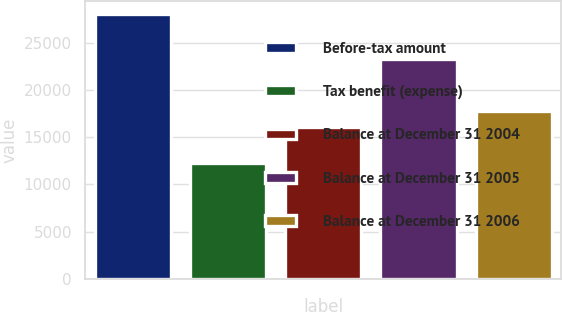Convert chart. <chart><loc_0><loc_0><loc_500><loc_500><bar_chart><fcel>Before-tax amount<fcel>Tax benefit (expense)<fcel>Balance at December 31 2004<fcel>Balance at December 31 2005<fcel>Balance at December 31 2006<nl><fcel>28048<fcel>12296<fcel>16066<fcel>23264<fcel>17784<nl></chart> 